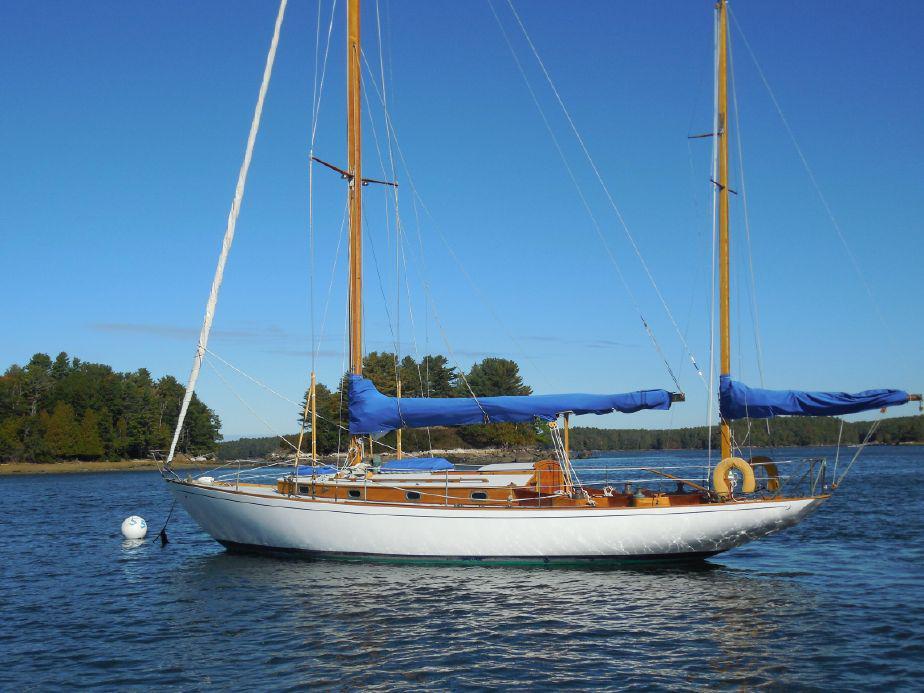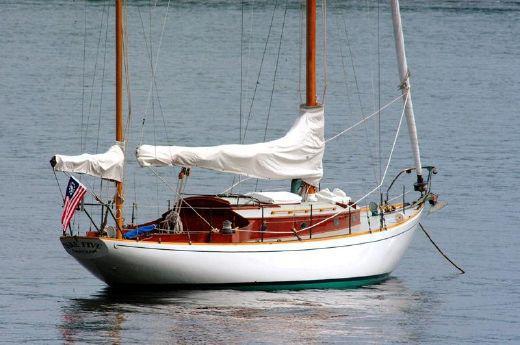The first image is the image on the left, the second image is the image on the right. Considering the images on both sides, is "The boat on the left doesn't have its sails up." valid? Answer yes or no. Yes. 